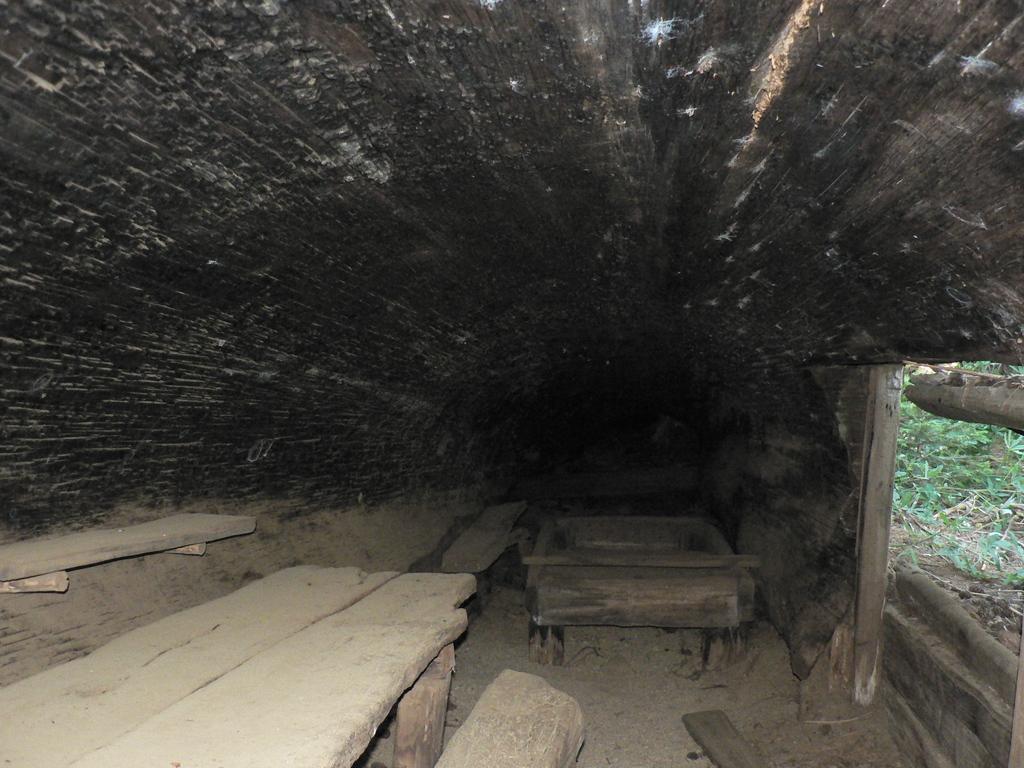In one or two sentences, can you explain what this image depicts? This picture shows couple of benches made of wood and we see plants and few wooden planks. 